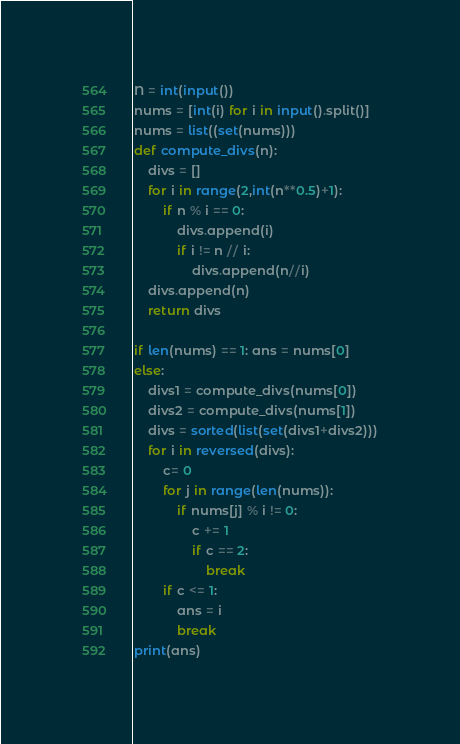<code> <loc_0><loc_0><loc_500><loc_500><_Python_>N = int(input())
nums = [int(i) for i in input().split()]
nums = list((set(nums)))
def compute_divs(n):
    divs = []
    for i in range(2,int(n**0.5)+1):
        if n % i == 0:
            divs.append(i)
            if i != n // i:
                divs.append(n//i)
    divs.append(n)
    return divs

if len(nums) == 1: ans = nums[0]
else:
    divs1 = compute_divs(nums[0])
    divs2 = compute_divs(nums[1])
    divs = sorted(list(set(divs1+divs2)))
    for i in reversed(divs):
        c= 0
        for j in range(len(nums)):
            if nums[j] % i != 0:
                c += 1
                if c == 2:
                    break
        if c <= 1:
            ans = i
            break
print(ans)</code> 